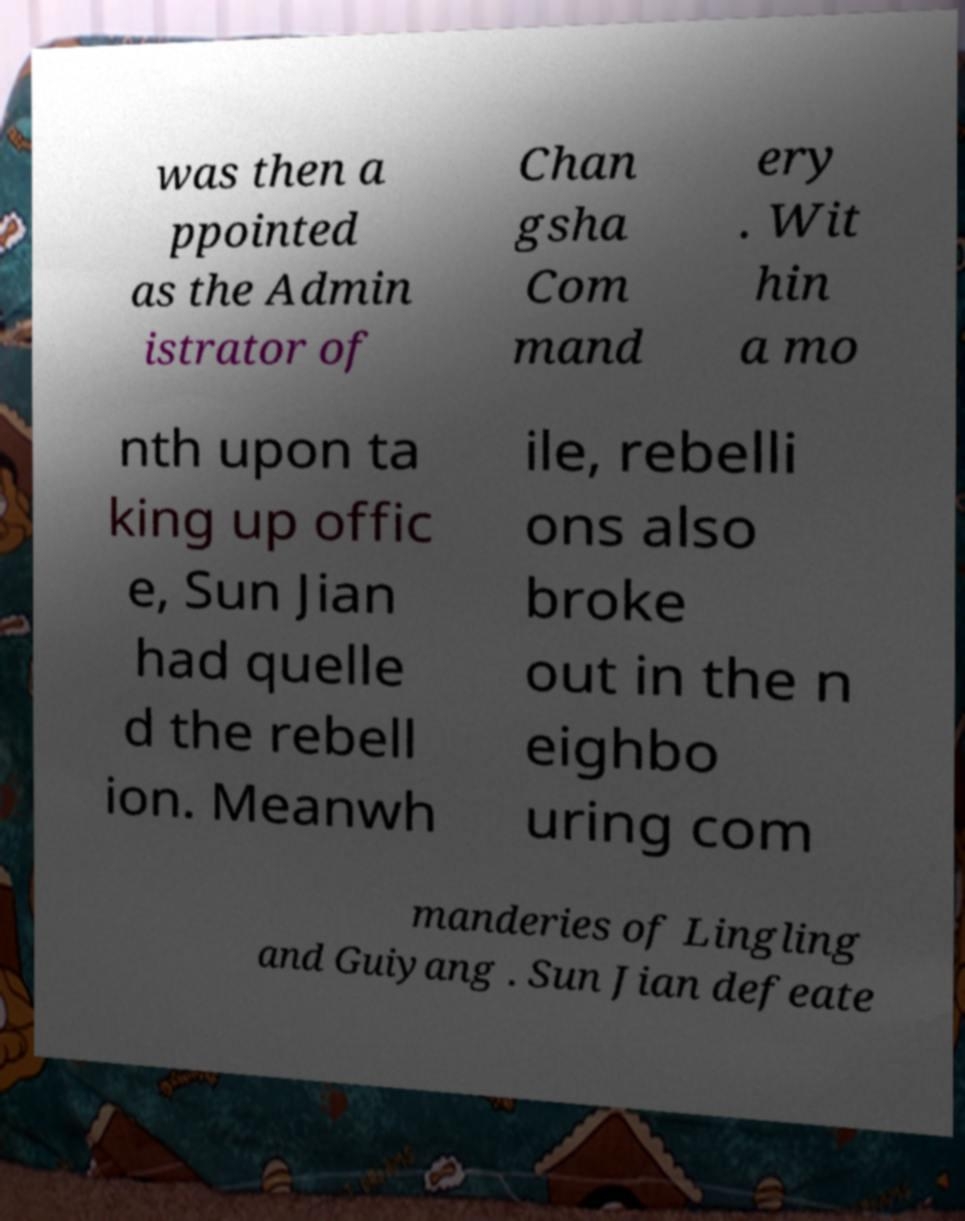I need the written content from this picture converted into text. Can you do that? was then a ppointed as the Admin istrator of Chan gsha Com mand ery . Wit hin a mo nth upon ta king up offic e, Sun Jian had quelle d the rebell ion. Meanwh ile, rebelli ons also broke out in the n eighbo uring com manderies of Lingling and Guiyang . Sun Jian defeate 